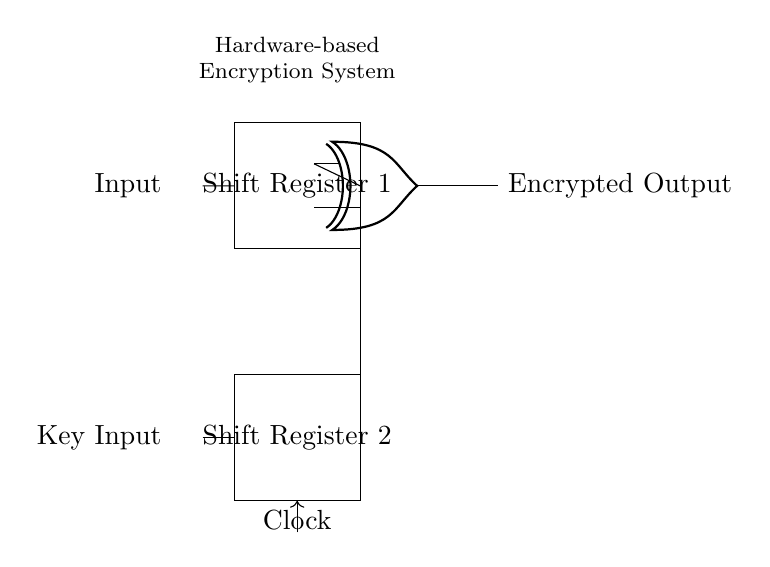What is the main purpose of this circuit? The main purpose is to encrypt data using a hardware-based encryption system. The combination of shift registers and XOR gates effectively obscures the original input data.
Answer: encryption What are the two shift registers labeled in the diagram? They are labeled as Shift Register 1 and Shift Register 2. Each plays a role in processing the input data sequentially.
Answer: Shift Register 1 and Shift Register 2 How many inputs does the XOR gate receive? The XOR gate receives two inputs: one from Shift Register 1 and one from the Key Input.
Answer: two What is the output of the XOR gate? The output of the XOR gate is labeled as Encrypted Output, representing the processed result of the input data and the key.
Answer: Encrypted Output Explain how the clock signal affects the shift registers. The clock signal synchronizes the operation of the shift registers, controlling when data shifts occur. It signals the registers to move their data bits in response, enabling the encrypted processing of input data.
Answer: synchronizes data shifting What type of circuit is represented here? This is a digital circuit, specifically designed for encryption using binary data manipulation. The components interact in a binary fashion to produce encrypted results.
Answer: digital circuit 